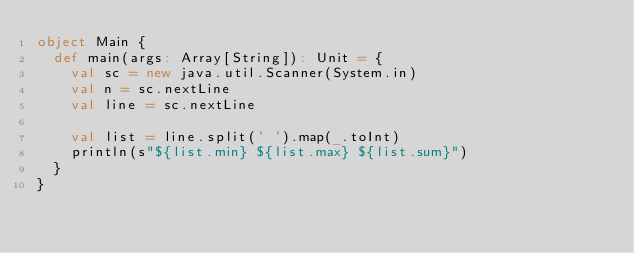Convert code to text. <code><loc_0><loc_0><loc_500><loc_500><_Scala_>object Main {
  def main(args: Array[String]): Unit = {
    val sc = new java.util.Scanner(System.in)
    val n = sc.nextLine
    val line = sc.nextLine

    val list = line.split(' ').map(_.toInt)
    println(s"${list.min} ${list.max} ${list.sum}")
  }
}</code> 